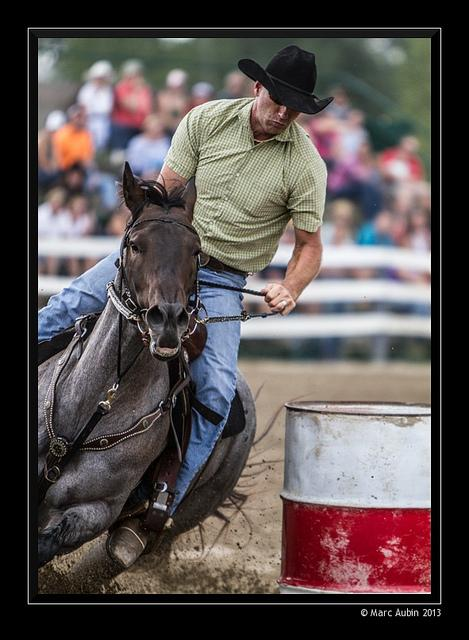What type activity does the man here take part in? rodeo 